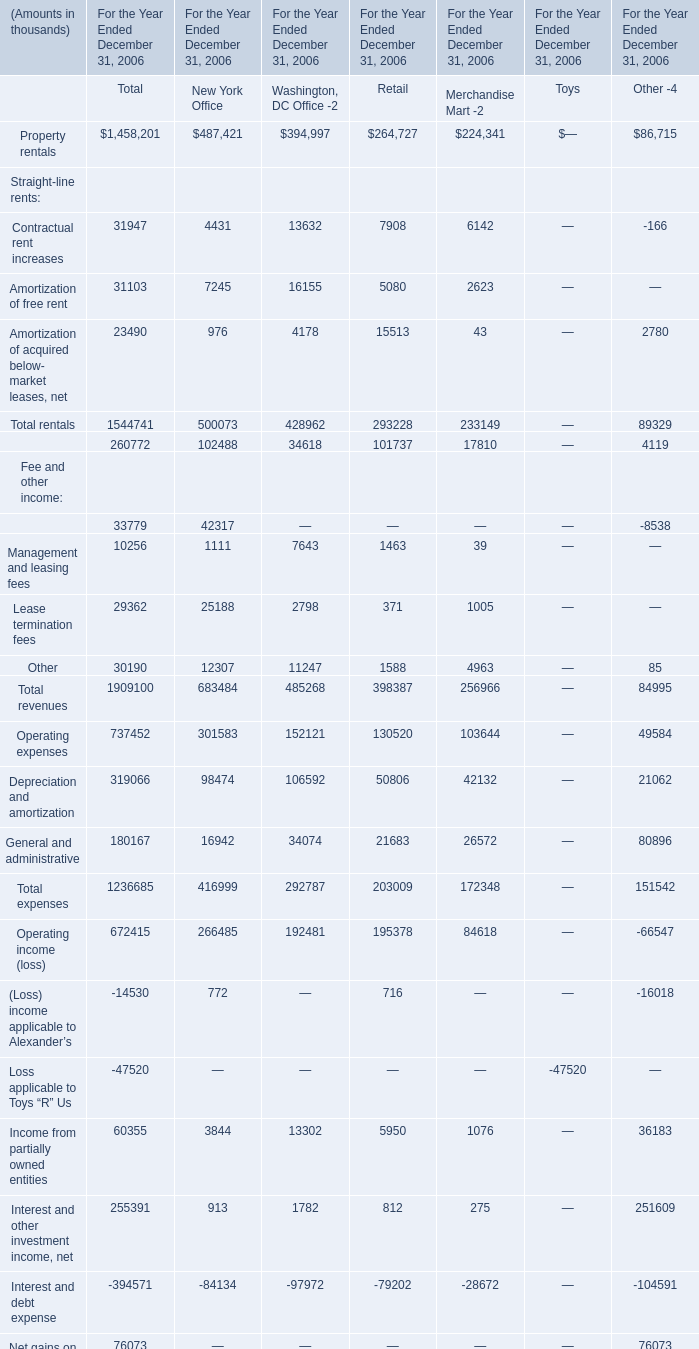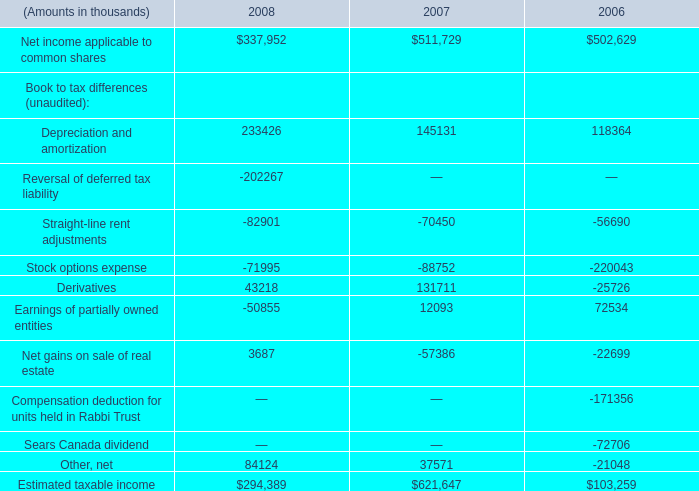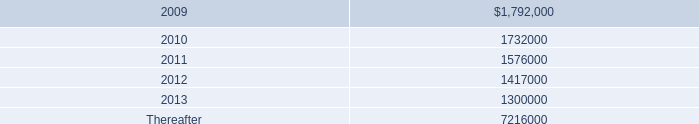percentage rents totaled what in thousands for the years ended december 31 , 2008 and 2007? 
Computations: (7322000 + 9379000)
Answer: 16701000.0. 